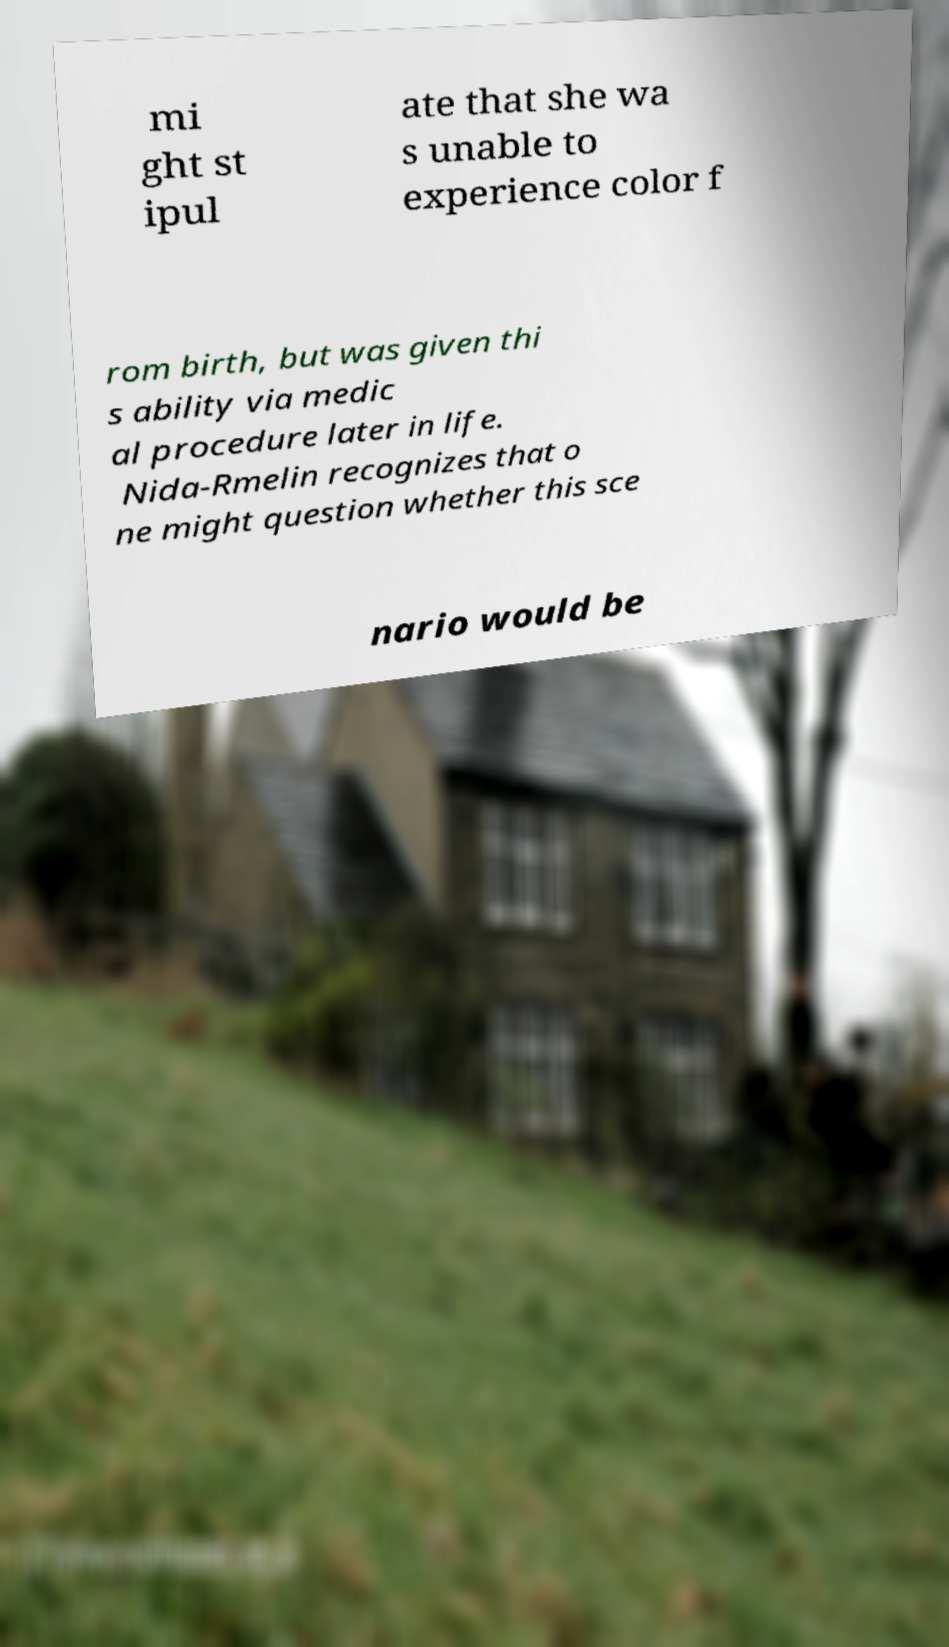There's text embedded in this image that I need extracted. Can you transcribe it verbatim? mi ght st ipul ate that she wa s unable to experience color f rom birth, but was given thi s ability via medic al procedure later in life. Nida-Rmelin recognizes that o ne might question whether this sce nario would be 